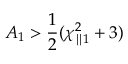Convert formula to latex. <formula><loc_0><loc_0><loc_500><loc_500>A _ { 1 } > \frac { 1 } { 2 } ( \chi _ { \| 1 } ^ { 2 } + 3 )</formula> 